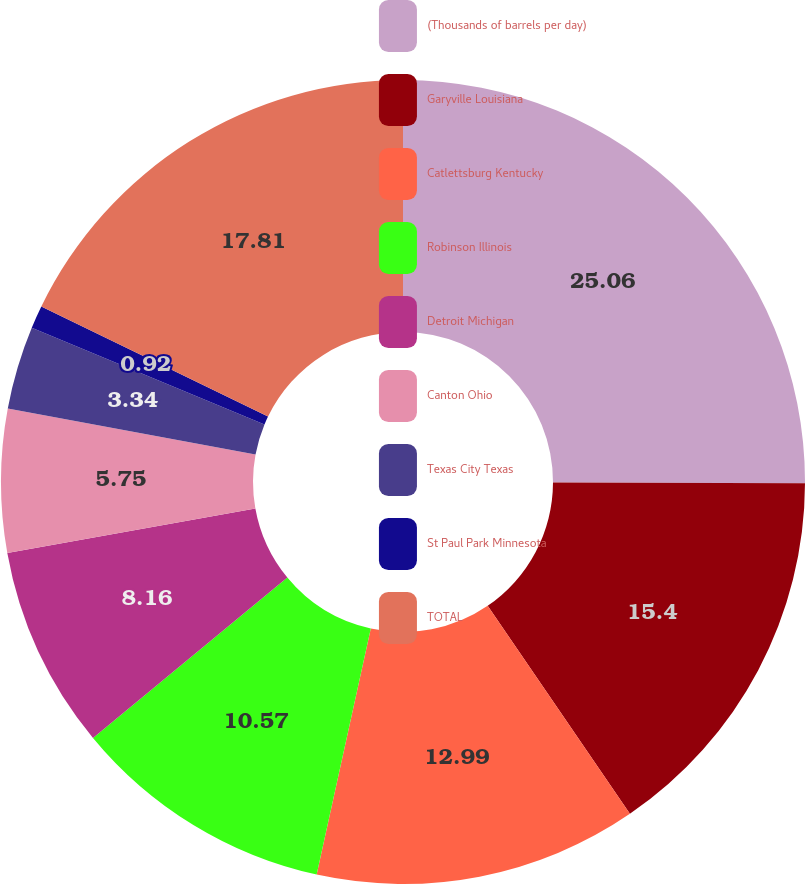Convert chart to OTSL. <chart><loc_0><loc_0><loc_500><loc_500><pie_chart><fcel>(Thousands of barrels per day)<fcel>Garyville Louisiana<fcel>Catlettsburg Kentucky<fcel>Robinson Illinois<fcel>Detroit Michigan<fcel>Canton Ohio<fcel>Texas City Texas<fcel>St Paul Park Minnesota<fcel>TOTAL<nl><fcel>25.05%<fcel>15.4%<fcel>12.99%<fcel>10.57%<fcel>8.16%<fcel>5.75%<fcel>3.34%<fcel>0.92%<fcel>17.81%<nl></chart> 